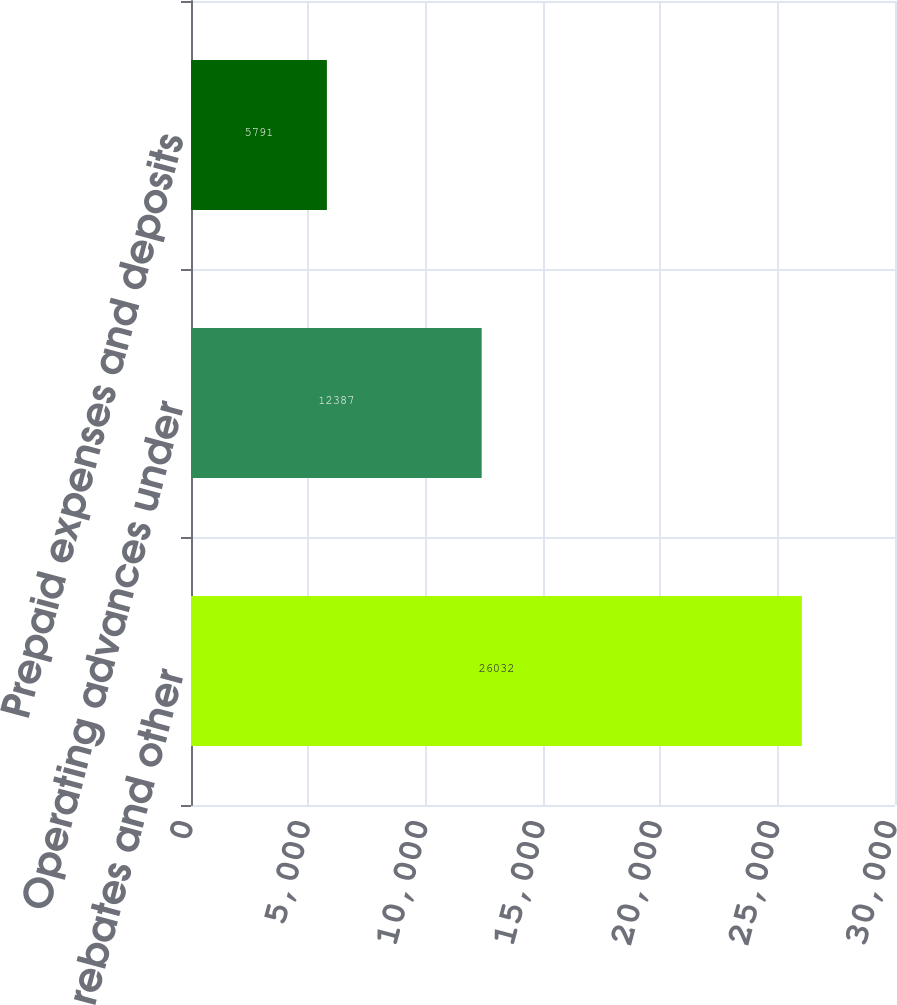Convert chart to OTSL. <chart><loc_0><loc_0><loc_500><loc_500><bar_chart><fcel>Supplier rebates and other<fcel>Operating advances under<fcel>Prepaid expenses and deposits<nl><fcel>26032<fcel>12387<fcel>5791<nl></chart> 